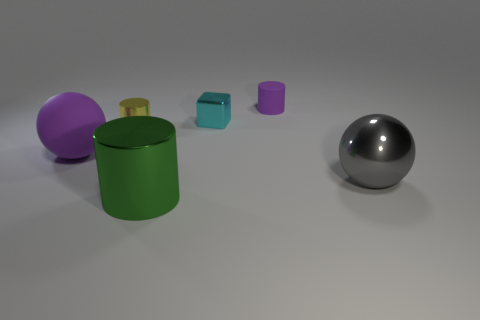Can you tell me the number of objects that have cylindrical shapes in the image? Certainly. In the image, there is one object with a cylindrical shape - the green cylindrical container located towards the left. 